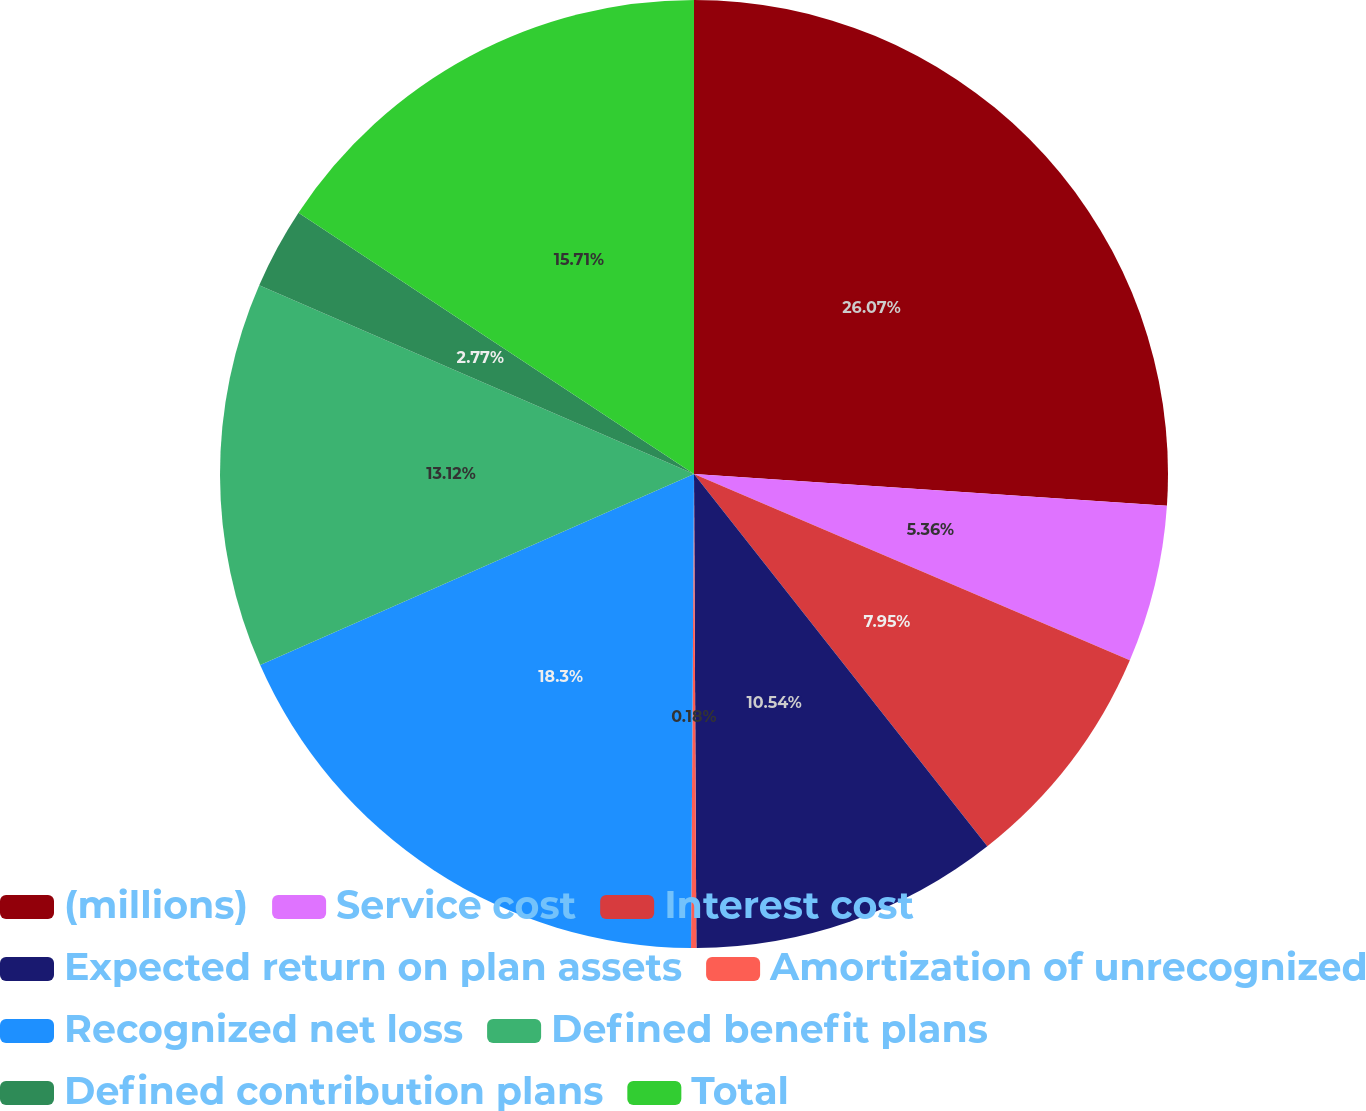<chart> <loc_0><loc_0><loc_500><loc_500><pie_chart><fcel>(millions)<fcel>Service cost<fcel>Interest cost<fcel>Expected return on plan assets<fcel>Amortization of unrecognized<fcel>Recognized net loss<fcel>Defined benefit plans<fcel>Defined contribution plans<fcel>Total<nl><fcel>26.07%<fcel>5.36%<fcel>7.95%<fcel>10.54%<fcel>0.18%<fcel>18.3%<fcel>13.12%<fcel>2.77%<fcel>15.71%<nl></chart> 